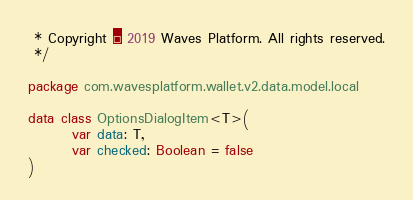Convert code to text. <code><loc_0><loc_0><loc_500><loc_500><_Kotlin_> * Copyright © 2019 Waves Platform. All rights reserved.
 */

package com.wavesplatform.wallet.v2.data.model.local

data class OptionsDialogItem<T>(
        var data: T,
        var checked: Boolean = false
)</code> 